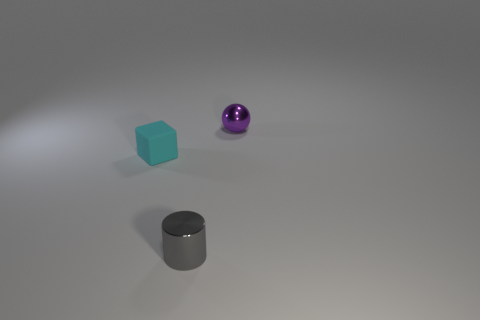Add 1 metal balls. How many objects exist? 4 Subtract all cylinders. How many objects are left? 2 Subtract all tiny yellow shiny cylinders. Subtract all small cyan cubes. How many objects are left? 2 Add 1 small purple things. How many small purple things are left? 2 Add 2 small cyan blocks. How many small cyan blocks exist? 3 Subtract 0 brown cubes. How many objects are left? 3 